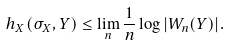<formula> <loc_0><loc_0><loc_500><loc_500>h _ { X } ( \sigma _ { X } , Y ) \leq \lim _ { n } \frac { 1 } { n } \log | W _ { n } ( Y ) | .</formula> 